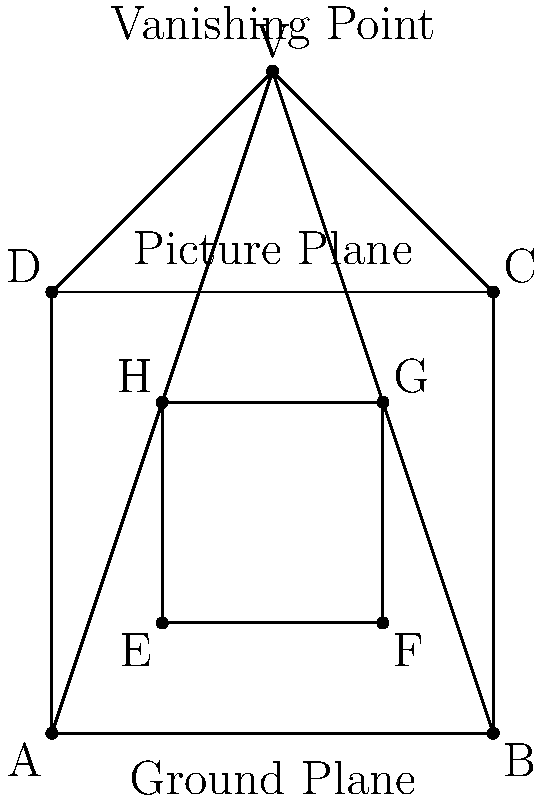In a Baroque-style architectural drawing, you're tasked with calculating the perspective of a square window within a larger square facade. The facade is represented by points ABCD, and the window by points EFGH. Given that the distance from the ground plane to the picture plane is 100 units, and the vanishing point V is 50 units above the picture plane, calculate the ratio of the apparent height of the window (EH) to the apparent height of the facade (AD) as seen from the viewer's perspective. To solve this problem, we'll use the principles of linear perspective and similar triangles:

1) In the ground plane, ABCD represents the facade, and EFGH represents the window.

2) The vanishing point V is 50 units above the picture plane, which is 100 units above the ground plane.

3) The apparent heights of the facade and window are determined by their projections onto the picture plane.

4) We can use similar triangles to find the ratio:

   $$\frac{EH}{AD} = \frac{VE' - VH'}{VA' - VD'}$$

   where E', H', A', and D' are the projections of E, H, A, and D onto the picture plane.

5) Due to the properties of perspective, we know that:
   
   $$\frac{VE'}{VA'} = \frac{VE}{VA} = \frac{125}{150} = \frac{5}{6}$$
   $$\frac{VH'}{VD'} = \frac{VH}{VD} = \frac{75}{150} = \frac{1}{2}$$

6) Now, we can calculate:

   $$\frac{EH}{AD} = \frac{VE' - VH'}{VA' - VD'} = \frac{VA' \cdot \frac{5}{6} - VD' \cdot \frac{1}{2}}{VA' - VD'}$$

7) Let $VA' = x$. Then $VD' = 50$ (since D is on the picture plane).

8) Substituting:

   $$\frac{EH}{AD} = \frac{x \cdot \frac{5}{6} - 50 \cdot \frac{1}{2}}{x - 50} = \frac{\frac{5x}{6} - 25}{x - 50}$$

9) This simplifies to:

   $$\frac{EH}{AD} = \frac{5x - 150}{6x - 300} = \frac{5}{6}$$

Therefore, the ratio of the apparent height of the window to the apparent height of the facade is 5:6.
Answer: 5:6 